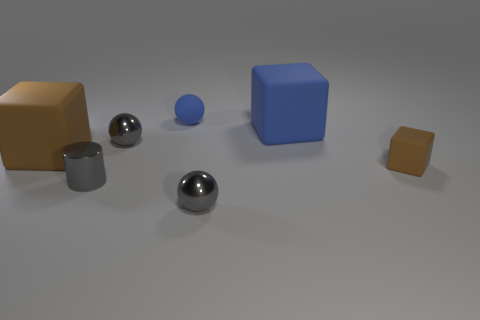Add 1 tiny rubber cubes. How many objects exist? 8 Subtract all big blocks. How many blocks are left? 1 Subtract all blue cylinders. How many brown cubes are left? 2 Subtract all blue blocks. How many blocks are left? 2 Subtract all cubes. How many objects are left? 4 Subtract 0 red blocks. How many objects are left? 7 Subtract 2 cubes. How many cubes are left? 1 Subtract all gray cubes. Subtract all brown cylinders. How many cubes are left? 3 Subtract all tiny gray metal things. Subtract all tiny cylinders. How many objects are left? 3 Add 2 small blue things. How many small blue things are left? 3 